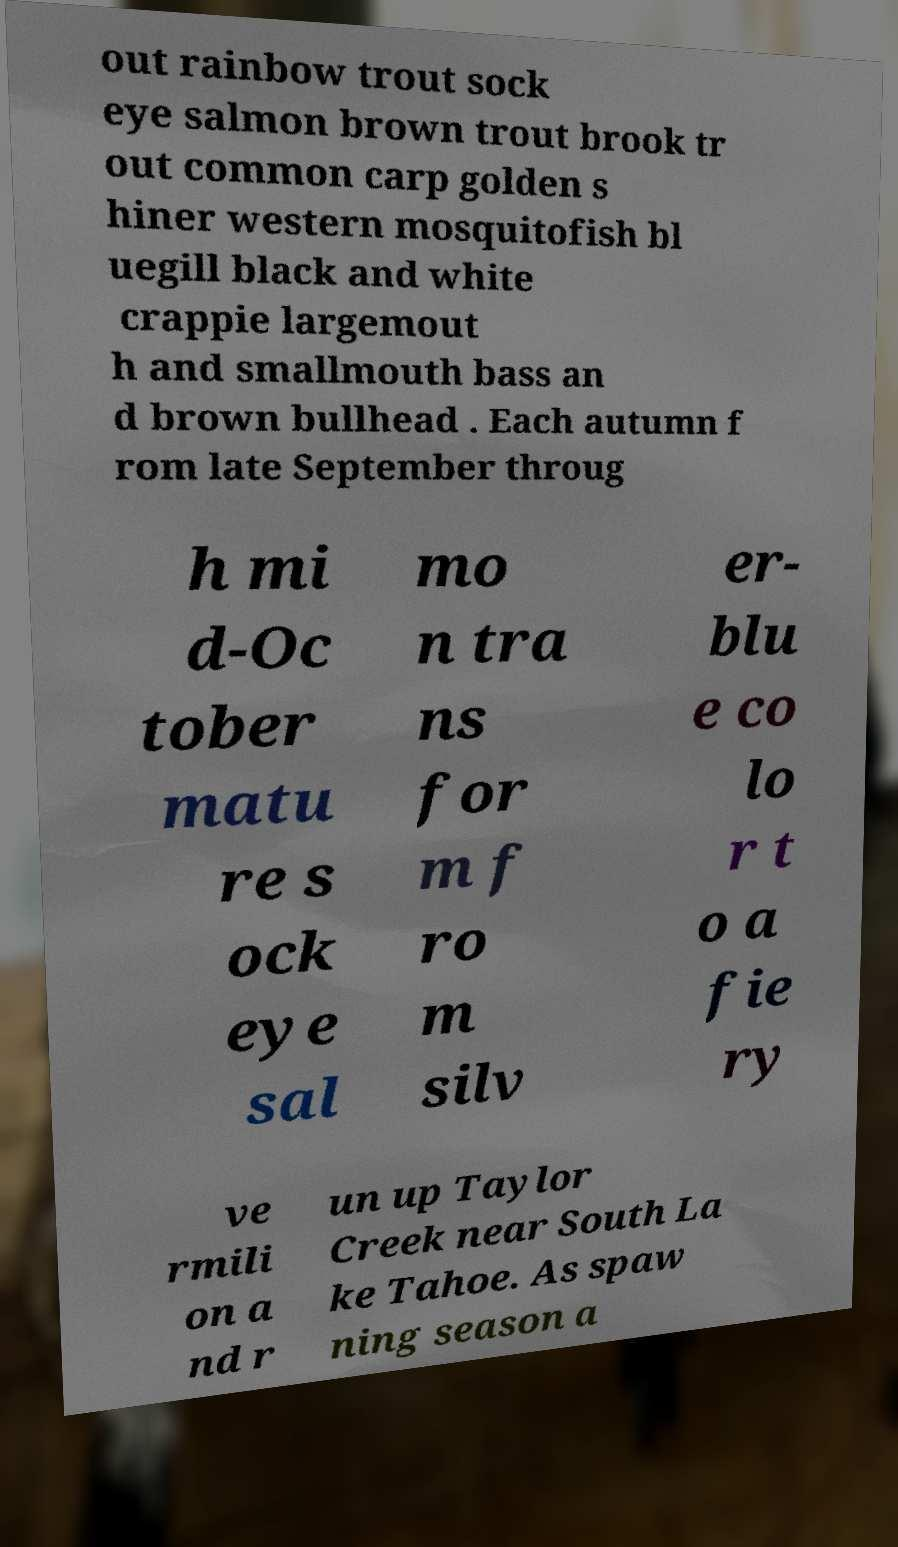Please read and relay the text visible in this image. What does it say? out rainbow trout sock eye salmon brown trout brook tr out common carp golden s hiner western mosquitofish bl uegill black and white crappie largemout h and smallmouth bass an d brown bullhead . Each autumn f rom late September throug h mi d-Oc tober matu re s ock eye sal mo n tra ns for m f ro m silv er- blu e co lo r t o a fie ry ve rmili on a nd r un up Taylor Creek near South La ke Tahoe. As spaw ning season a 